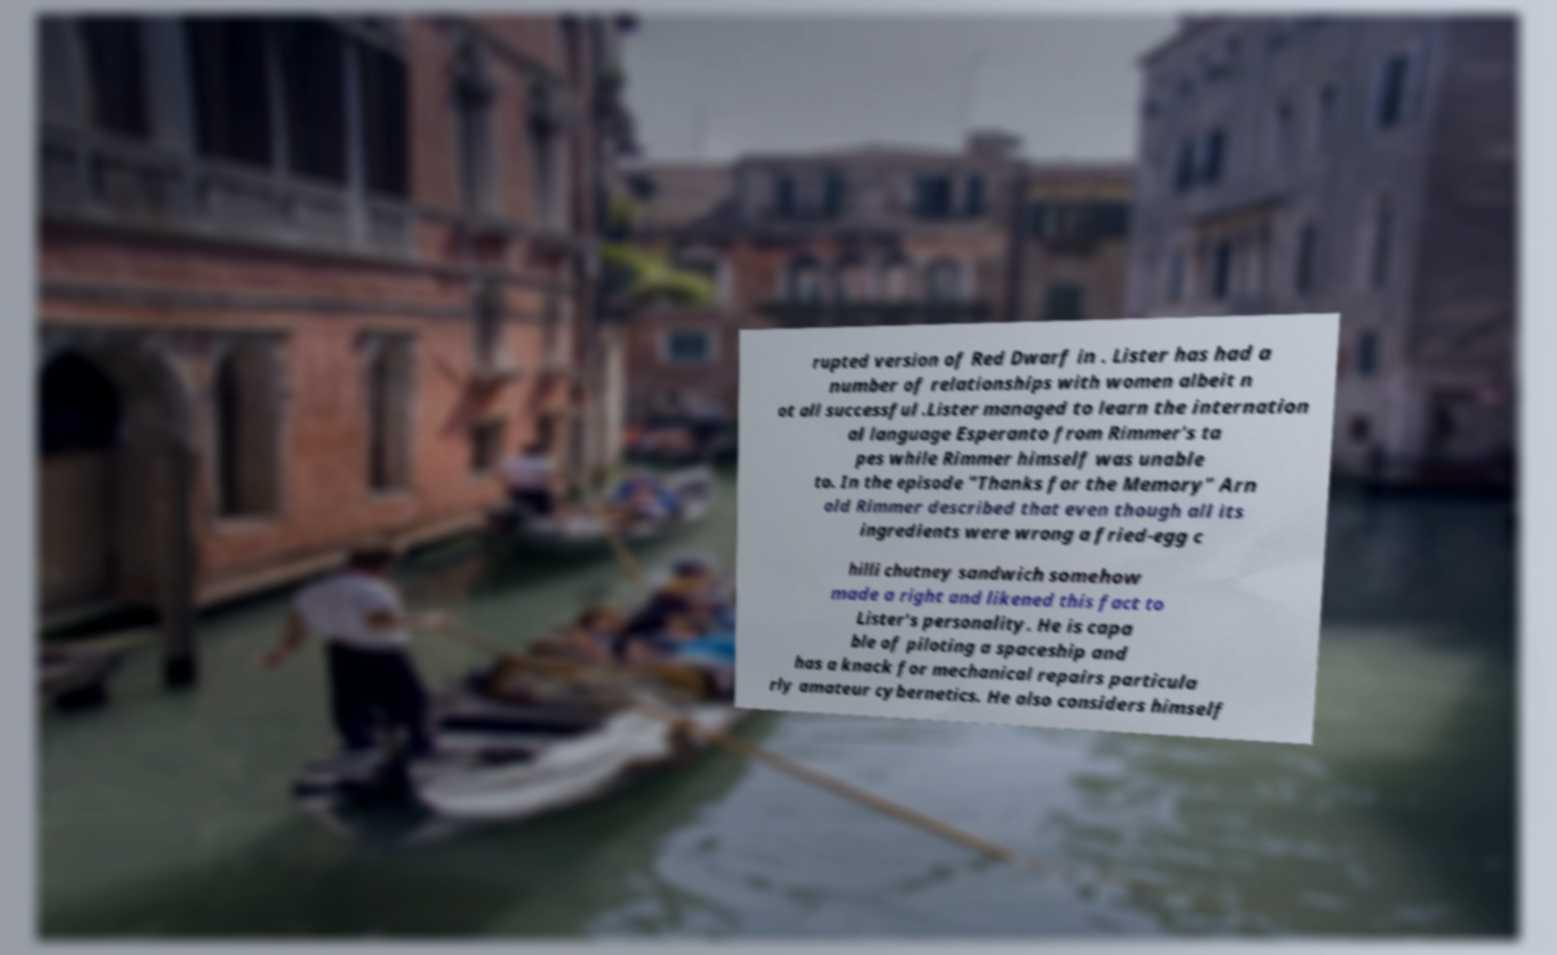Could you assist in decoding the text presented in this image and type it out clearly? rupted version of Red Dwarf in . Lister has had a number of relationships with women albeit n ot all successful .Lister managed to learn the internation al language Esperanto from Rimmer's ta pes while Rimmer himself was unable to. In the episode "Thanks for the Memory" Arn old Rimmer described that even though all its ingredients were wrong a fried-egg c hilli chutney sandwich somehow made a right and likened this fact to Lister's personality. He is capa ble of piloting a spaceship and has a knack for mechanical repairs particula rly amateur cybernetics. He also considers himself 